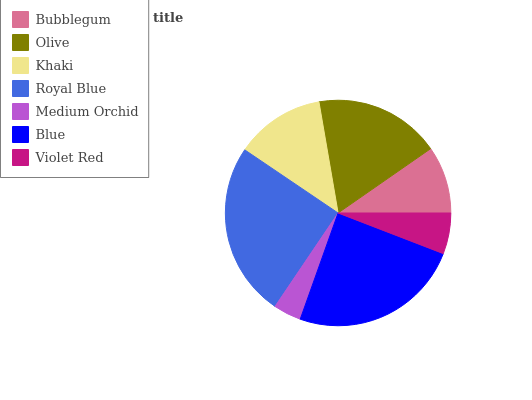Is Medium Orchid the minimum?
Answer yes or no. Yes. Is Royal Blue the maximum?
Answer yes or no. Yes. Is Olive the minimum?
Answer yes or no. No. Is Olive the maximum?
Answer yes or no. No. Is Olive greater than Bubblegum?
Answer yes or no. Yes. Is Bubblegum less than Olive?
Answer yes or no. Yes. Is Bubblegum greater than Olive?
Answer yes or no. No. Is Olive less than Bubblegum?
Answer yes or no. No. Is Khaki the high median?
Answer yes or no. Yes. Is Khaki the low median?
Answer yes or no. Yes. Is Royal Blue the high median?
Answer yes or no. No. Is Blue the low median?
Answer yes or no. No. 